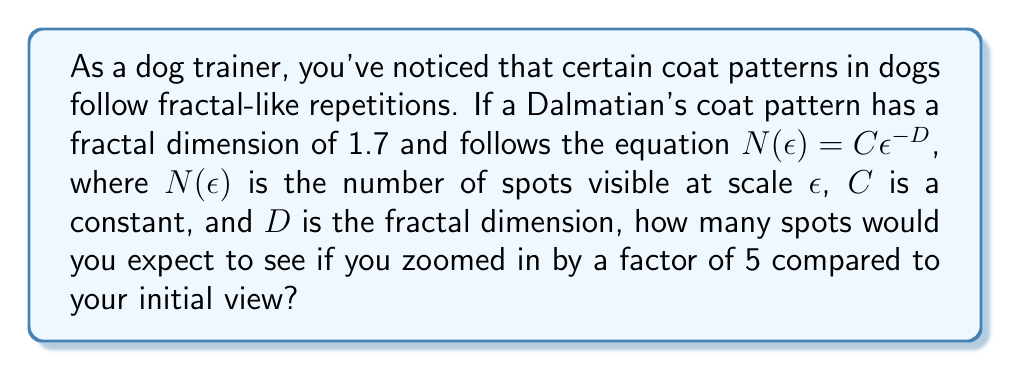Teach me how to tackle this problem. Let's approach this step-by-step:

1) The fractal dimension $D$ is given as 1.7.

2) We're using the equation $N(\epsilon) = C\epsilon^{-D}$

3) Let's call the initial number of spots $N_1$ and the number of spots after zooming in $N_2$. The initial scale is $\epsilon_1$ and the zoomed scale is $\epsilon_2$.

4) We know that $\epsilon_2 = \epsilon_1 / 5$ because we're zooming in by a factor of 5.

5) We can write two equations:
   $N_1 = C\epsilon_1^{-D}$
   $N_2 = C\epsilon_2^{-D} = C(\epsilon_1/5)^{-D}$

6) Dividing these equations:
   $$\frac{N_2}{N_1} = \frac{C(\epsilon_1/5)^{-D}}{C\epsilon_1^{-D}} = (1/5)^{-D} = 5^D$$

7) Substituting $D = 1.7$:
   $$\frac{N_2}{N_1} = 5^{1.7} \approx 13.9565$$

8) This means you would expect to see about 13.9565 times as many spots after zooming in.
Answer: $13.9565$ times more spots 